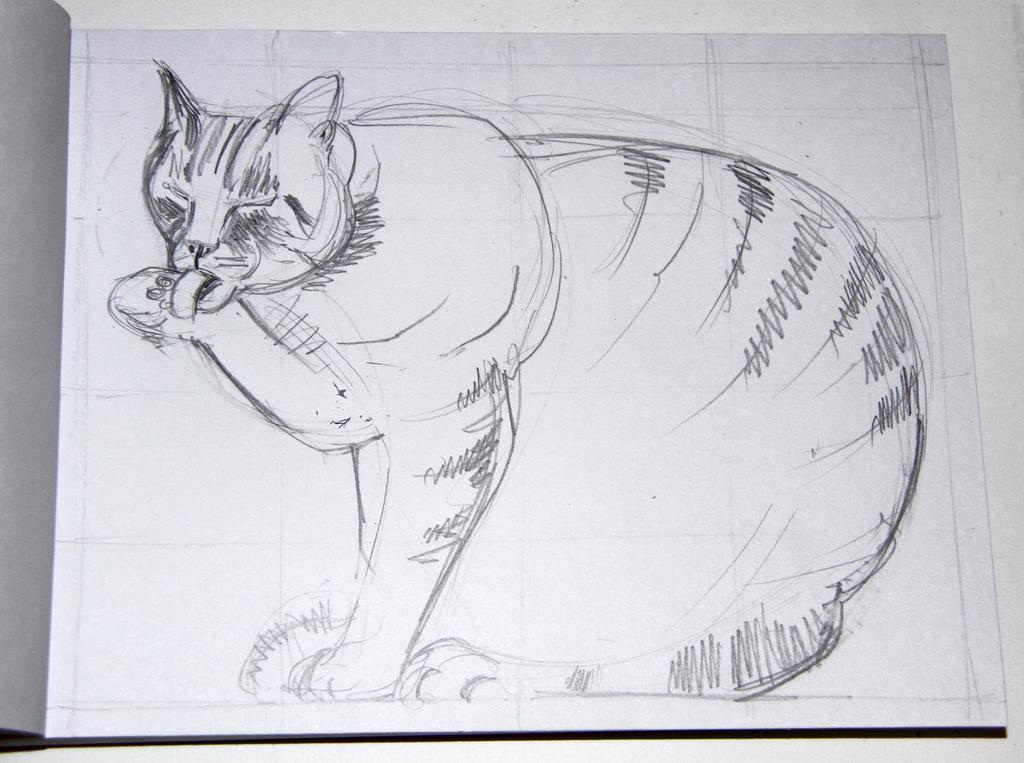In one or two sentences, can you explain what this image depicts? In this picture we can see a paper and on the paper there is a drawing of a cat and the paper is on an object. 